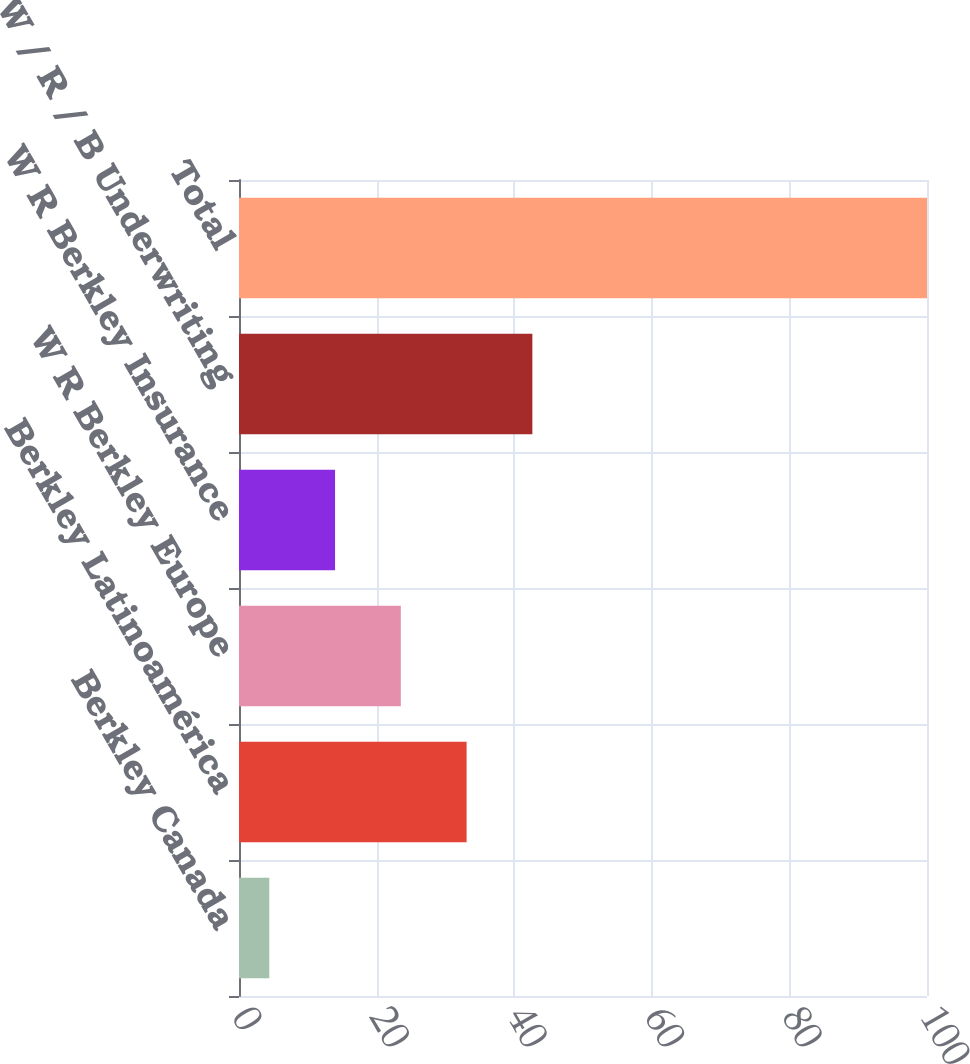Convert chart to OTSL. <chart><loc_0><loc_0><loc_500><loc_500><bar_chart><fcel>Berkley Canada<fcel>Berkley Latinoamérica<fcel>W R Berkley Europe<fcel>W R Berkley Insurance<fcel>W / R / B Underwriting<fcel>Total<nl><fcel>4.4<fcel>33.08<fcel>23.52<fcel>13.96<fcel>42.64<fcel>100<nl></chart> 